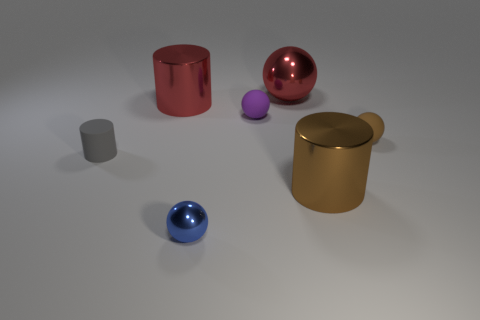Can you describe the smallest object in the scene? The smallest object in the scene is a small purple sphere, resting near the center of the image, in front of the large yellow cylindrical container. 